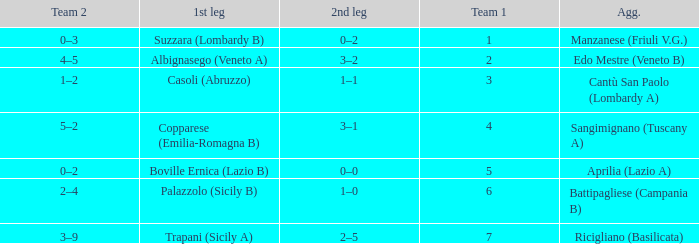What is the mean team 1 when the 1st leg is Albignasego (Veneto A)? 2.0. 